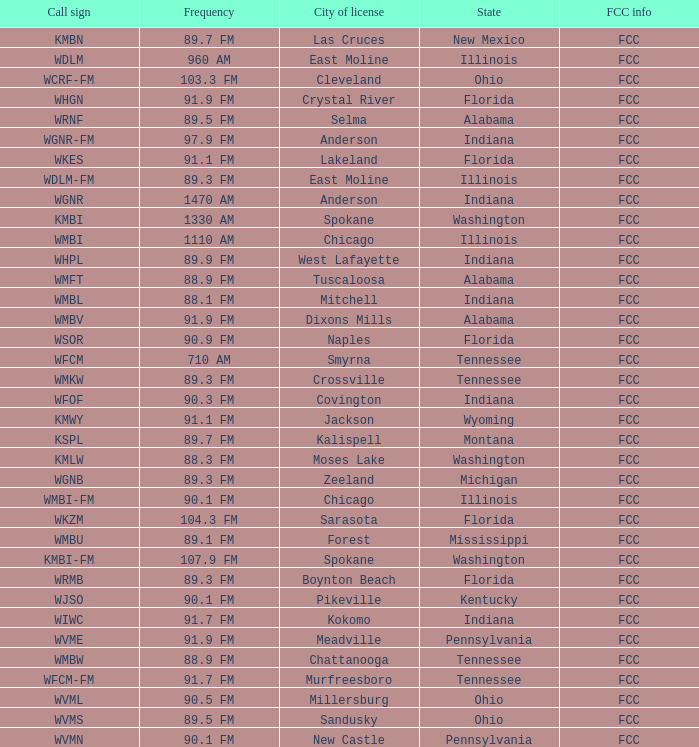What is the call sign for 90.9 FM which is in Florida? WSOR. 